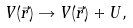Convert formula to latex. <formula><loc_0><loc_0><loc_500><loc_500>V ( \vec { r } ) \rightarrow V ( \vec { r } ) + U ,</formula> 